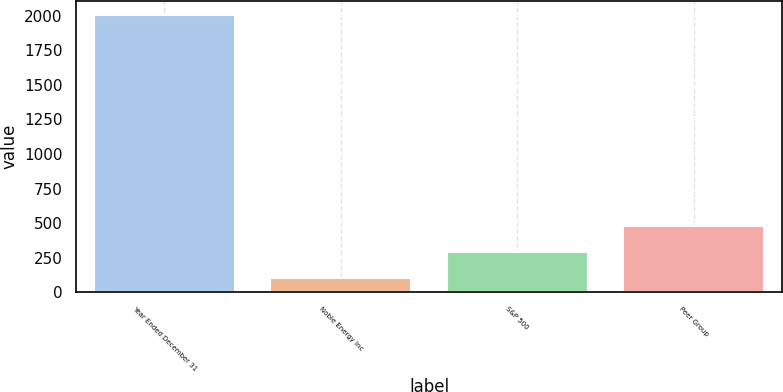Convert chart. <chart><loc_0><loc_0><loc_500><loc_500><bar_chart><fcel>Year Ended December 31<fcel>Noble Energy Inc<fcel>S&P 500<fcel>Peer Group<nl><fcel>2004<fcel>100<fcel>290.4<fcel>480.8<nl></chart> 